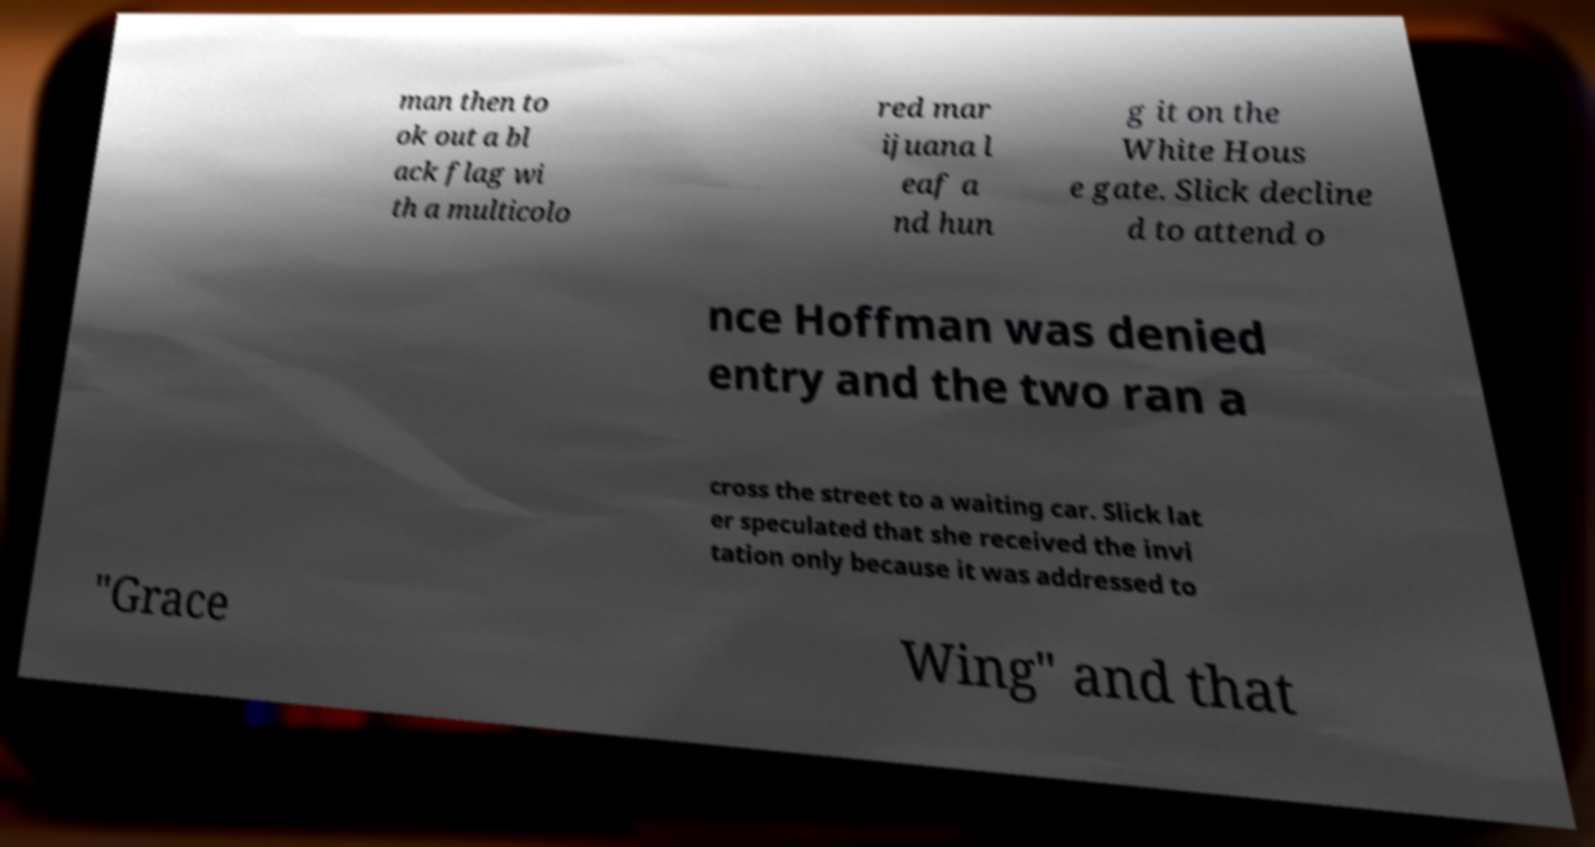Can you read and provide the text displayed in the image?This photo seems to have some interesting text. Can you extract and type it out for me? man then to ok out a bl ack flag wi th a multicolo red mar ijuana l eaf a nd hun g it on the White Hous e gate. Slick decline d to attend o nce Hoffman was denied entry and the two ran a cross the street to a waiting car. Slick lat er speculated that she received the invi tation only because it was addressed to "Grace Wing" and that 